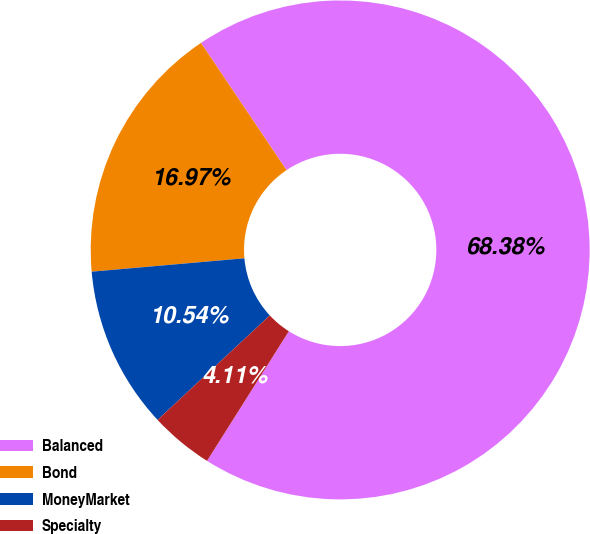Convert chart. <chart><loc_0><loc_0><loc_500><loc_500><pie_chart><fcel>Balanced<fcel>Bond<fcel>MoneyMarket<fcel>Specialty<nl><fcel>68.38%<fcel>16.97%<fcel>10.54%<fcel>4.11%<nl></chart> 